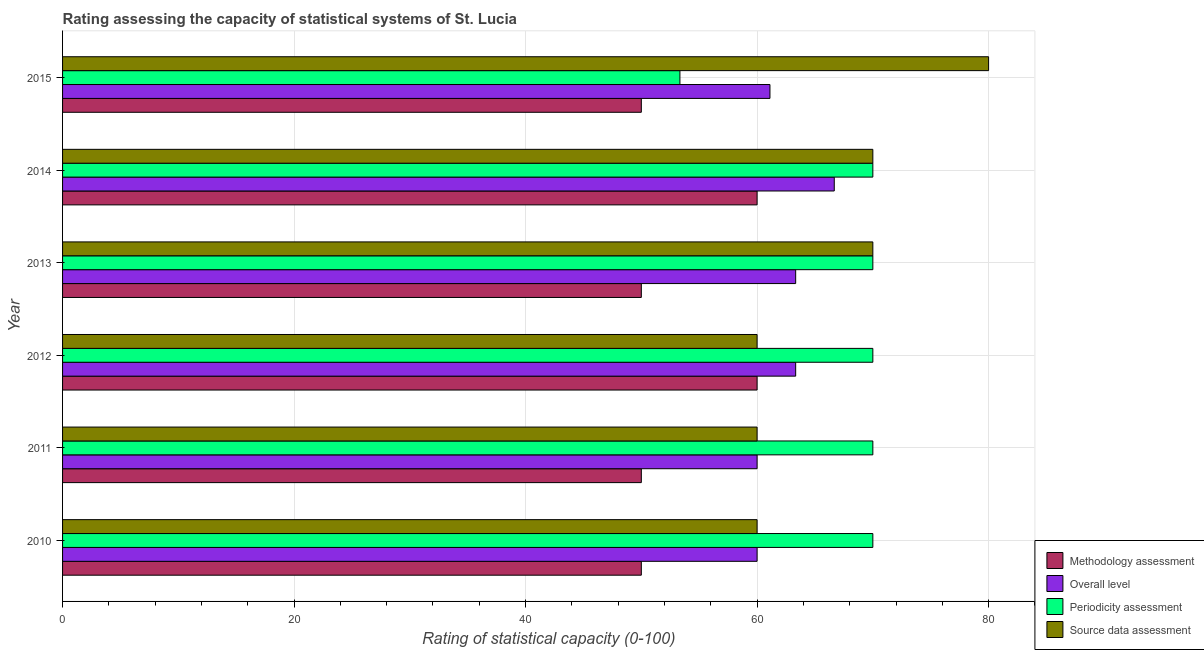How many groups of bars are there?
Provide a succinct answer. 6. What is the label of the 1st group of bars from the top?
Offer a terse response. 2015. What is the periodicity assessment rating in 2015?
Your answer should be very brief. 53.33. Across all years, what is the maximum methodology assessment rating?
Make the answer very short. 60. Across all years, what is the minimum overall level rating?
Offer a very short reply. 60. In which year was the source data assessment rating maximum?
Provide a short and direct response. 2015. In which year was the overall level rating minimum?
Ensure brevity in your answer.  2010. What is the total source data assessment rating in the graph?
Offer a terse response. 400. What is the difference between the methodology assessment rating in 2010 and the periodicity assessment rating in 2011?
Your response must be concise. -20. What is the average methodology assessment rating per year?
Your answer should be compact. 53.33. In the year 2011, what is the difference between the overall level rating and periodicity assessment rating?
Keep it short and to the point. -10. In how many years, is the overall level rating greater than 8 ?
Your answer should be very brief. 6. What is the ratio of the methodology assessment rating in 2010 to that in 2011?
Offer a terse response. 1. Is the overall level rating in 2010 less than that in 2015?
Your response must be concise. Yes. Is the difference between the source data assessment rating in 2011 and 2013 greater than the difference between the overall level rating in 2011 and 2013?
Give a very brief answer. No. What is the difference between the highest and the second highest overall level rating?
Provide a succinct answer. 3.33. What is the difference between the highest and the lowest methodology assessment rating?
Your answer should be compact. 10. Is the sum of the overall level rating in 2010 and 2012 greater than the maximum source data assessment rating across all years?
Give a very brief answer. Yes. What does the 3rd bar from the top in 2012 represents?
Provide a short and direct response. Overall level. What does the 2nd bar from the bottom in 2010 represents?
Provide a short and direct response. Overall level. Are all the bars in the graph horizontal?
Give a very brief answer. Yes. What is the difference between two consecutive major ticks on the X-axis?
Provide a succinct answer. 20. Does the graph contain any zero values?
Your answer should be very brief. No. Does the graph contain grids?
Your answer should be compact. Yes. What is the title of the graph?
Make the answer very short. Rating assessing the capacity of statistical systems of St. Lucia. What is the label or title of the X-axis?
Your answer should be very brief. Rating of statistical capacity (0-100). What is the Rating of statistical capacity (0-100) in Methodology assessment in 2010?
Provide a short and direct response. 50. What is the Rating of statistical capacity (0-100) of Overall level in 2010?
Your answer should be very brief. 60. What is the Rating of statistical capacity (0-100) of Periodicity assessment in 2011?
Make the answer very short. 70. What is the Rating of statistical capacity (0-100) of Overall level in 2012?
Provide a succinct answer. 63.33. What is the Rating of statistical capacity (0-100) in Periodicity assessment in 2012?
Your response must be concise. 70. What is the Rating of statistical capacity (0-100) of Source data assessment in 2012?
Ensure brevity in your answer.  60. What is the Rating of statistical capacity (0-100) in Methodology assessment in 2013?
Give a very brief answer. 50. What is the Rating of statistical capacity (0-100) of Overall level in 2013?
Provide a succinct answer. 63.33. What is the Rating of statistical capacity (0-100) of Source data assessment in 2013?
Offer a terse response. 70. What is the Rating of statistical capacity (0-100) in Methodology assessment in 2014?
Provide a short and direct response. 60. What is the Rating of statistical capacity (0-100) in Overall level in 2014?
Offer a terse response. 66.67. What is the Rating of statistical capacity (0-100) of Methodology assessment in 2015?
Provide a short and direct response. 50. What is the Rating of statistical capacity (0-100) of Overall level in 2015?
Make the answer very short. 61.11. What is the Rating of statistical capacity (0-100) in Periodicity assessment in 2015?
Offer a terse response. 53.33. What is the Rating of statistical capacity (0-100) of Source data assessment in 2015?
Offer a very short reply. 80. Across all years, what is the maximum Rating of statistical capacity (0-100) of Overall level?
Give a very brief answer. 66.67. Across all years, what is the minimum Rating of statistical capacity (0-100) of Methodology assessment?
Give a very brief answer. 50. Across all years, what is the minimum Rating of statistical capacity (0-100) in Overall level?
Ensure brevity in your answer.  60. Across all years, what is the minimum Rating of statistical capacity (0-100) of Periodicity assessment?
Ensure brevity in your answer.  53.33. Across all years, what is the minimum Rating of statistical capacity (0-100) of Source data assessment?
Your answer should be compact. 60. What is the total Rating of statistical capacity (0-100) of Methodology assessment in the graph?
Provide a short and direct response. 320. What is the total Rating of statistical capacity (0-100) in Overall level in the graph?
Provide a succinct answer. 374.44. What is the total Rating of statistical capacity (0-100) in Periodicity assessment in the graph?
Your answer should be compact. 403.33. What is the total Rating of statistical capacity (0-100) in Source data assessment in the graph?
Your answer should be very brief. 400. What is the difference between the Rating of statistical capacity (0-100) in Methodology assessment in 2010 and that in 2011?
Your answer should be very brief. 0. What is the difference between the Rating of statistical capacity (0-100) in Overall level in 2010 and that in 2011?
Ensure brevity in your answer.  0. What is the difference between the Rating of statistical capacity (0-100) in Periodicity assessment in 2010 and that in 2011?
Give a very brief answer. 0. What is the difference between the Rating of statistical capacity (0-100) of Source data assessment in 2010 and that in 2012?
Give a very brief answer. 0. What is the difference between the Rating of statistical capacity (0-100) in Periodicity assessment in 2010 and that in 2013?
Offer a terse response. 0. What is the difference between the Rating of statistical capacity (0-100) in Source data assessment in 2010 and that in 2013?
Provide a succinct answer. -10. What is the difference between the Rating of statistical capacity (0-100) in Overall level in 2010 and that in 2014?
Make the answer very short. -6.67. What is the difference between the Rating of statistical capacity (0-100) of Methodology assessment in 2010 and that in 2015?
Keep it short and to the point. 0. What is the difference between the Rating of statistical capacity (0-100) of Overall level in 2010 and that in 2015?
Your response must be concise. -1.11. What is the difference between the Rating of statistical capacity (0-100) of Periodicity assessment in 2010 and that in 2015?
Ensure brevity in your answer.  16.67. What is the difference between the Rating of statistical capacity (0-100) of Source data assessment in 2010 and that in 2015?
Your answer should be very brief. -20. What is the difference between the Rating of statistical capacity (0-100) in Methodology assessment in 2011 and that in 2012?
Offer a very short reply. -10. What is the difference between the Rating of statistical capacity (0-100) in Overall level in 2011 and that in 2012?
Provide a short and direct response. -3.33. What is the difference between the Rating of statistical capacity (0-100) of Periodicity assessment in 2011 and that in 2012?
Your answer should be compact. 0. What is the difference between the Rating of statistical capacity (0-100) of Source data assessment in 2011 and that in 2012?
Offer a very short reply. 0. What is the difference between the Rating of statistical capacity (0-100) in Methodology assessment in 2011 and that in 2014?
Offer a very short reply. -10. What is the difference between the Rating of statistical capacity (0-100) in Overall level in 2011 and that in 2014?
Give a very brief answer. -6.67. What is the difference between the Rating of statistical capacity (0-100) of Periodicity assessment in 2011 and that in 2014?
Your answer should be very brief. 0. What is the difference between the Rating of statistical capacity (0-100) of Overall level in 2011 and that in 2015?
Offer a very short reply. -1.11. What is the difference between the Rating of statistical capacity (0-100) of Periodicity assessment in 2011 and that in 2015?
Provide a succinct answer. 16.67. What is the difference between the Rating of statistical capacity (0-100) of Overall level in 2012 and that in 2013?
Provide a succinct answer. 0. What is the difference between the Rating of statistical capacity (0-100) in Periodicity assessment in 2012 and that in 2013?
Make the answer very short. 0. What is the difference between the Rating of statistical capacity (0-100) in Source data assessment in 2012 and that in 2013?
Provide a short and direct response. -10. What is the difference between the Rating of statistical capacity (0-100) in Methodology assessment in 2012 and that in 2014?
Ensure brevity in your answer.  0. What is the difference between the Rating of statistical capacity (0-100) of Overall level in 2012 and that in 2014?
Your response must be concise. -3.33. What is the difference between the Rating of statistical capacity (0-100) of Periodicity assessment in 2012 and that in 2014?
Keep it short and to the point. 0. What is the difference between the Rating of statistical capacity (0-100) of Source data assessment in 2012 and that in 2014?
Provide a short and direct response. -10. What is the difference between the Rating of statistical capacity (0-100) in Overall level in 2012 and that in 2015?
Your answer should be very brief. 2.22. What is the difference between the Rating of statistical capacity (0-100) in Periodicity assessment in 2012 and that in 2015?
Your response must be concise. 16.67. What is the difference between the Rating of statistical capacity (0-100) of Source data assessment in 2012 and that in 2015?
Provide a succinct answer. -20. What is the difference between the Rating of statistical capacity (0-100) in Overall level in 2013 and that in 2014?
Provide a succinct answer. -3.33. What is the difference between the Rating of statistical capacity (0-100) of Periodicity assessment in 2013 and that in 2014?
Provide a short and direct response. 0. What is the difference between the Rating of statistical capacity (0-100) in Source data assessment in 2013 and that in 2014?
Your answer should be compact. 0. What is the difference between the Rating of statistical capacity (0-100) in Methodology assessment in 2013 and that in 2015?
Your answer should be compact. 0. What is the difference between the Rating of statistical capacity (0-100) in Overall level in 2013 and that in 2015?
Offer a very short reply. 2.22. What is the difference between the Rating of statistical capacity (0-100) of Periodicity assessment in 2013 and that in 2015?
Offer a very short reply. 16.67. What is the difference between the Rating of statistical capacity (0-100) in Source data assessment in 2013 and that in 2015?
Your answer should be compact. -10. What is the difference between the Rating of statistical capacity (0-100) of Methodology assessment in 2014 and that in 2015?
Ensure brevity in your answer.  10. What is the difference between the Rating of statistical capacity (0-100) in Overall level in 2014 and that in 2015?
Your response must be concise. 5.56. What is the difference between the Rating of statistical capacity (0-100) of Periodicity assessment in 2014 and that in 2015?
Provide a succinct answer. 16.67. What is the difference between the Rating of statistical capacity (0-100) in Methodology assessment in 2010 and the Rating of statistical capacity (0-100) in Source data assessment in 2011?
Give a very brief answer. -10. What is the difference between the Rating of statistical capacity (0-100) of Overall level in 2010 and the Rating of statistical capacity (0-100) of Periodicity assessment in 2011?
Ensure brevity in your answer.  -10. What is the difference between the Rating of statistical capacity (0-100) in Methodology assessment in 2010 and the Rating of statistical capacity (0-100) in Overall level in 2012?
Provide a succinct answer. -13.33. What is the difference between the Rating of statistical capacity (0-100) of Methodology assessment in 2010 and the Rating of statistical capacity (0-100) of Periodicity assessment in 2012?
Give a very brief answer. -20. What is the difference between the Rating of statistical capacity (0-100) of Methodology assessment in 2010 and the Rating of statistical capacity (0-100) of Source data assessment in 2012?
Your response must be concise. -10. What is the difference between the Rating of statistical capacity (0-100) of Overall level in 2010 and the Rating of statistical capacity (0-100) of Periodicity assessment in 2012?
Give a very brief answer. -10. What is the difference between the Rating of statistical capacity (0-100) in Methodology assessment in 2010 and the Rating of statistical capacity (0-100) in Overall level in 2013?
Offer a very short reply. -13.33. What is the difference between the Rating of statistical capacity (0-100) of Methodology assessment in 2010 and the Rating of statistical capacity (0-100) of Periodicity assessment in 2013?
Give a very brief answer. -20. What is the difference between the Rating of statistical capacity (0-100) of Methodology assessment in 2010 and the Rating of statistical capacity (0-100) of Source data assessment in 2013?
Ensure brevity in your answer.  -20. What is the difference between the Rating of statistical capacity (0-100) in Overall level in 2010 and the Rating of statistical capacity (0-100) in Periodicity assessment in 2013?
Keep it short and to the point. -10. What is the difference between the Rating of statistical capacity (0-100) of Overall level in 2010 and the Rating of statistical capacity (0-100) of Source data assessment in 2013?
Make the answer very short. -10. What is the difference between the Rating of statistical capacity (0-100) of Periodicity assessment in 2010 and the Rating of statistical capacity (0-100) of Source data assessment in 2013?
Give a very brief answer. 0. What is the difference between the Rating of statistical capacity (0-100) of Methodology assessment in 2010 and the Rating of statistical capacity (0-100) of Overall level in 2014?
Ensure brevity in your answer.  -16.67. What is the difference between the Rating of statistical capacity (0-100) of Methodology assessment in 2010 and the Rating of statistical capacity (0-100) of Periodicity assessment in 2014?
Make the answer very short. -20. What is the difference between the Rating of statistical capacity (0-100) of Methodology assessment in 2010 and the Rating of statistical capacity (0-100) of Source data assessment in 2014?
Your response must be concise. -20. What is the difference between the Rating of statistical capacity (0-100) of Overall level in 2010 and the Rating of statistical capacity (0-100) of Source data assessment in 2014?
Provide a short and direct response. -10. What is the difference between the Rating of statistical capacity (0-100) in Periodicity assessment in 2010 and the Rating of statistical capacity (0-100) in Source data assessment in 2014?
Keep it short and to the point. 0. What is the difference between the Rating of statistical capacity (0-100) of Methodology assessment in 2010 and the Rating of statistical capacity (0-100) of Overall level in 2015?
Ensure brevity in your answer.  -11.11. What is the difference between the Rating of statistical capacity (0-100) in Methodology assessment in 2010 and the Rating of statistical capacity (0-100) in Source data assessment in 2015?
Make the answer very short. -30. What is the difference between the Rating of statistical capacity (0-100) of Periodicity assessment in 2010 and the Rating of statistical capacity (0-100) of Source data assessment in 2015?
Ensure brevity in your answer.  -10. What is the difference between the Rating of statistical capacity (0-100) of Methodology assessment in 2011 and the Rating of statistical capacity (0-100) of Overall level in 2012?
Offer a terse response. -13.33. What is the difference between the Rating of statistical capacity (0-100) in Methodology assessment in 2011 and the Rating of statistical capacity (0-100) in Periodicity assessment in 2012?
Provide a succinct answer. -20. What is the difference between the Rating of statistical capacity (0-100) in Methodology assessment in 2011 and the Rating of statistical capacity (0-100) in Source data assessment in 2012?
Give a very brief answer. -10. What is the difference between the Rating of statistical capacity (0-100) in Methodology assessment in 2011 and the Rating of statistical capacity (0-100) in Overall level in 2013?
Your answer should be compact. -13.33. What is the difference between the Rating of statistical capacity (0-100) in Methodology assessment in 2011 and the Rating of statistical capacity (0-100) in Periodicity assessment in 2013?
Your response must be concise. -20. What is the difference between the Rating of statistical capacity (0-100) of Methodology assessment in 2011 and the Rating of statistical capacity (0-100) of Overall level in 2014?
Keep it short and to the point. -16.67. What is the difference between the Rating of statistical capacity (0-100) in Overall level in 2011 and the Rating of statistical capacity (0-100) in Periodicity assessment in 2014?
Offer a terse response. -10. What is the difference between the Rating of statistical capacity (0-100) of Methodology assessment in 2011 and the Rating of statistical capacity (0-100) of Overall level in 2015?
Offer a very short reply. -11.11. What is the difference between the Rating of statistical capacity (0-100) in Methodology assessment in 2011 and the Rating of statistical capacity (0-100) in Source data assessment in 2015?
Ensure brevity in your answer.  -30. What is the difference between the Rating of statistical capacity (0-100) of Overall level in 2011 and the Rating of statistical capacity (0-100) of Source data assessment in 2015?
Keep it short and to the point. -20. What is the difference between the Rating of statistical capacity (0-100) of Periodicity assessment in 2011 and the Rating of statistical capacity (0-100) of Source data assessment in 2015?
Ensure brevity in your answer.  -10. What is the difference between the Rating of statistical capacity (0-100) of Methodology assessment in 2012 and the Rating of statistical capacity (0-100) of Periodicity assessment in 2013?
Offer a terse response. -10. What is the difference between the Rating of statistical capacity (0-100) of Overall level in 2012 and the Rating of statistical capacity (0-100) of Periodicity assessment in 2013?
Offer a very short reply. -6.67. What is the difference between the Rating of statistical capacity (0-100) in Overall level in 2012 and the Rating of statistical capacity (0-100) in Source data assessment in 2013?
Make the answer very short. -6.67. What is the difference between the Rating of statistical capacity (0-100) in Periodicity assessment in 2012 and the Rating of statistical capacity (0-100) in Source data assessment in 2013?
Give a very brief answer. 0. What is the difference between the Rating of statistical capacity (0-100) of Methodology assessment in 2012 and the Rating of statistical capacity (0-100) of Overall level in 2014?
Your answer should be compact. -6.67. What is the difference between the Rating of statistical capacity (0-100) in Overall level in 2012 and the Rating of statistical capacity (0-100) in Periodicity assessment in 2014?
Your response must be concise. -6.67. What is the difference between the Rating of statistical capacity (0-100) in Overall level in 2012 and the Rating of statistical capacity (0-100) in Source data assessment in 2014?
Ensure brevity in your answer.  -6.67. What is the difference between the Rating of statistical capacity (0-100) in Methodology assessment in 2012 and the Rating of statistical capacity (0-100) in Overall level in 2015?
Your answer should be compact. -1.11. What is the difference between the Rating of statistical capacity (0-100) in Methodology assessment in 2012 and the Rating of statistical capacity (0-100) in Periodicity assessment in 2015?
Keep it short and to the point. 6.67. What is the difference between the Rating of statistical capacity (0-100) in Overall level in 2012 and the Rating of statistical capacity (0-100) in Periodicity assessment in 2015?
Make the answer very short. 10. What is the difference between the Rating of statistical capacity (0-100) of Overall level in 2012 and the Rating of statistical capacity (0-100) of Source data assessment in 2015?
Keep it short and to the point. -16.67. What is the difference between the Rating of statistical capacity (0-100) of Periodicity assessment in 2012 and the Rating of statistical capacity (0-100) of Source data assessment in 2015?
Keep it short and to the point. -10. What is the difference between the Rating of statistical capacity (0-100) in Methodology assessment in 2013 and the Rating of statistical capacity (0-100) in Overall level in 2014?
Your response must be concise. -16.67. What is the difference between the Rating of statistical capacity (0-100) of Methodology assessment in 2013 and the Rating of statistical capacity (0-100) of Source data assessment in 2014?
Give a very brief answer. -20. What is the difference between the Rating of statistical capacity (0-100) in Overall level in 2013 and the Rating of statistical capacity (0-100) in Periodicity assessment in 2014?
Your answer should be compact. -6.67. What is the difference between the Rating of statistical capacity (0-100) in Overall level in 2013 and the Rating of statistical capacity (0-100) in Source data assessment in 2014?
Keep it short and to the point. -6.67. What is the difference between the Rating of statistical capacity (0-100) in Methodology assessment in 2013 and the Rating of statistical capacity (0-100) in Overall level in 2015?
Give a very brief answer. -11.11. What is the difference between the Rating of statistical capacity (0-100) of Methodology assessment in 2013 and the Rating of statistical capacity (0-100) of Periodicity assessment in 2015?
Provide a succinct answer. -3.33. What is the difference between the Rating of statistical capacity (0-100) in Overall level in 2013 and the Rating of statistical capacity (0-100) in Source data assessment in 2015?
Your answer should be very brief. -16.67. What is the difference between the Rating of statistical capacity (0-100) of Methodology assessment in 2014 and the Rating of statistical capacity (0-100) of Overall level in 2015?
Provide a short and direct response. -1.11. What is the difference between the Rating of statistical capacity (0-100) in Methodology assessment in 2014 and the Rating of statistical capacity (0-100) in Periodicity assessment in 2015?
Provide a short and direct response. 6.67. What is the difference between the Rating of statistical capacity (0-100) of Methodology assessment in 2014 and the Rating of statistical capacity (0-100) of Source data assessment in 2015?
Provide a short and direct response. -20. What is the difference between the Rating of statistical capacity (0-100) of Overall level in 2014 and the Rating of statistical capacity (0-100) of Periodicity assessment in 2015?
Make the answer very short. 13.33. What is the difference between the Rating of statistical capacity (0-100) in Overall level in 2014 and the Rating of statistical capacity (0-100) in Source data assessment in 2015?
Give a very brief answer. -13.33. What is the difference between the Rating of statistical capacity (0-100) of Periodicity assessment in 2014 and the Rating of statistical capacity (0-100) of Source data assessment in 2015?
Provide a succinct answer. -10. What is the average Rating of statistical capacity (0-100) of Methodology assessment per year?
Make the answer very short. 53.33. What is the average Rating of statistical capacity (0-100) in Overall level per year?
Offer a very short reply. 62.41. What is the average Rating of statistical capacity (0-100) of Periodicity assessment per year?
Provide a short and direct response. 67.22. What is the average Rating of statistical capacity (0-100) in Source data assessment per year?
Make the answer very short. 66.67. In the year 2010, what is the difference between the Rating of statistical capacity (0-100) of Methodology assessment and Rating of statistical capacity (0-100) of Overall level?
Offer a terse response. -10. In the year 2010, what is the difference between the Rating of statistical capacity (0-100) of Overall level and Rating of statistical capacity (0-100) of Periodicity assessment?
Make the answer very short. -10. In the year 2011, what is the difference between the Rating of statistical capacity (0-100) of Methodology assessment and Rating of statistical capacity (0-100) of Overall level?
Make the answer very short. -10. In the year 2011, what is the difference between the Rating of statistical capacity (0-100) in Methodology assessment and Rating of statistical capacity (0-100) in Source data assessment?
Provide a short and direct response. -10. In the year 2011, what is the difference between the Rating of statistical capacity (0-100) in Overall level and Rating of statistical capacity (0-100) in Periodicity assessment?
Provide a succinct answer. -10. In the year 2011, what is the difference between the Rating of statistical capacity (0-100) in Overall level and Rating of statistical capacity (0-100) in Source data assessment?
Your answer should be very brief. 0. In the year 2012, what is the difference between the Rating of statistical capacity (0-100) of Methodology assessment and Rating of statistical capacity (0-100) of Overall level?
Make the answer very short. -3.33. In the year 2012, what is the difference between the Rating of statistical capacity (0-100) in Methodology assessment and Rating of statistical capacity (0-100) in Periodicity assessment?
Offer a very short reply. -10. In the year 2012, what is the difference between the Rating of statistical capacity (0-100) in Overall level and Rating of statistical capacity (0-100) in Periodicity assessment?
Give a very brief answer. -6.67. In the year 2012, what is the difference between the Rating of statistical capacity (0-100) in Overall level and Rating of statistical capacity (0-100) in Source data assessment?
Provide a succinct answer. 3.33. In the year 2012, what is the difference between the Rating of statistical capacity (0-100) of Periodicity assessment and Rating of statistical capacity (0-100) of Source data assessment?
Give a very brief answer. 10. In the year 2013, what is the difference between the Rating of statistical capacity (0-100) in Methodology assessment and Rating of statistical capacity (0-100) in Overall level?
Make the answer very short. -13.33. In the year 2013, what is the difference between the Rating of statistical capacity (0-100) in Methodology assessment and Rating of statistical capacity (0-100) in Periodicity assessment?
Your answer should be very brief. -20. In the year 2013, what is the difference between the Rating of statistical capacity (0-100) in Methodology assessment and Rating of statistical capacity (0-100) in Source data assessment?
Make the answer very short. -20. In the year 2013, what is the difference between the Rating of statistical capacity (0-100) of Overall level and Rating of statistical capacity (0-100) of Periodicity assessment?
Your response must be concise. -6.67. In the year 2013, what is the difference between the Rating of statistical capacity (0-100) of Overall level and Rating of statistical capacity (0-100) of Source data assessment?
Your answer should be very brief. -6.67. In the year 2014, what is the difference between the Rating of statistical capacity (0-100) in Methodology assessment and Rating of statistical capacity (0-100) in Overall level?
Your answer should be compact. -6.67. In the year 2014, what is the difference between the Rating of statistical capacity (0-100) of Methodology assessment and Rating of statistical capacity (0-100) of Source data assessment?
Keep it short and to the point. -10. In the year 2014, what is the difference between the Rating of statistical capacity (0-100) in Overall level and Rating of statistical capacity (0-100) in Periodicity assessment?
Provide a short and direct response. -3.33. In the year 2015, what is the difference between the Rating of statistical capacity (0-100) in Methodology assessment and Rating of statistical capacity (0-100) in Overall level?
Provide a short and direct response. -11.11. In the year 2015, what is the difference between the Rating of statistical capacity (0-100) in Methodology assessment and Rating of statistical capacity (0-100) in Source data assessment?
Your response must be concise. -30. In the year 2015, what is the difference between the Rating of statistical capacity (0-100) in Overall level and Rating of statistical capacity (0-100) in Periodicity assessment?
Offer a very short reply. 7.78. In the year 2015, what is the difference between the Rating of statistical capacity (0-100) of Overall level and Rating of statistical capacity (0-100) of Source data assessment?
Give a very brief answer. -18.89. In the year 2015, what is the difference between the Rating of statistical capacity (0-100) of Periodicity assessment and Rating of statistical capacity (0-100) of Source data assessment?
Your answer should be very brief. -26.67. What is the ratio of the Rating of statistical capacity (0-100) in Methodology assessment in 2010 to that in 2012?
Give a very brief answer. 0.83. What is the ratio of the Rating of statistical capacity (0-100) of Overall level in 2010 to that in 2012?
Your answer should be compact. 0.95. What is the ratio of the Rating of statistical capacity (0-100) of Periodicity assessment in 2010 to that in 2012?
Provide a succinct answer. 1. What is the ratio of the Rating of statistical capacity (0-100) in Source data assessment in 2010 to that in 2012?
Keep it short and to the point. 1. What is the ratio of the Rating of statistical capacity (0-100) in Methodology assessment in 2010 to that in 2013?
Ensure brevity in your answer.  1. What is the ratio of the Rating of statistical capacity (0-100) in Overall level in 2010 to that in 2014?
Give a very brief answer. 0.9. What is the ratio of the Rating of statistical capacity (0-100) in Periodicity assessment in 2010 to that in 2014?
Give a very brief answer. 1. What is the ratio of the Rating of statistical capacity (0-100) in Methodology assessment in 2010 to that in 2015?
Your response must be concise. 1. What is the ratio of the Rating of statistical capacity (0-100) in Overall level in 2010 to that in 2015?
Give a very brief answer. 0.98. What is the ratio of the Rating of statistical capacity (0-100) of Periodicity assessment in 2010 to that in 2015?
Offer a very short reply. 1.31. What is the ratio of the Rating of statistical capacity (0-100) in Source data assessment in 2010 to that in 2015?
Offer a very short reply. 0.75. What is the ratio of the Rating of statistical capacity (0-100) of Methodology assessment in 2011 to that in 2013?
Your answer should be very brief. 1. What is the ratio of the Rating of statistical capacity (0-100) of Source data assessment in 2011 to that in 2013?
Your response must be concise. 0.86. What is the ratio of the Rating of statistical capacity (0-100) in Methodology assessment in 2011 to that in 2014?
Give a very brief answer. 0.83. What is the ratio of the Rating of statistical capacity (0-100) of Overall level in 2011 to that in 2014?
Provide a short and direct response. 0.9. What is the ratio of the Rating of statistical capacity (0-100) of Periodicity assessment in 2011 to that in 2014?
Your answer should be compact. 1. What is the ratio of the Rating of statistical capacity (0-100) in Source data assessment in 2011 to that in 2014?
Provide a succinct answer. 0.86. What is the ratio of the Rating of statistical capacity (0-100) of Overall level in 2011 to that in 2015?
Give a very brief answer. 0.98. What is the ratio of the Rating of statistical capacity (0-100) of Periodicity assessment in 2011 to that in 2015?
Offer a terse response. 1.31. What is the ratio of the Rating of statistical capacity (0-100) in Methodology assessment in 2012 to that in 2013?
Offer a very short reply. 1.2. What is the ratio of the Rating of statistical capacity (0-100) in Periodicity assessment in 2012 to that in 2013?
Offer a very short reply. 1. What is the ratio of the Rating of statistical capacity (0-100) in Source data assessment in 2012 to that in 2013?
Provide a short and direct response. 0.86. What is the ratio of the Rating of statistical capacity (0-100) of Source data assessment in 2012 to that in 2014?
Your answer should be compact. 0.86. What is the ratio of the Rating of statistical capacity (0-100) of Methodology assessment in 2012 to that in 2015?
Offer a terse response. 1.2. What is the ratio of the Rating of statistical capacity (0-100) in Overall level in 2012 to that in 2015?
Offer a very short reply. 1.04. What is the ratio of the Rating of statistical capacity (0-100) of Periodicity assessment in 2012 to that in 2015?
Provide a succinct answer. 1.31. What is the ratio of the Rating of statistical capacity (0-100) of Source data assessment in 2012 to that in 2015?
Provide a short and direct response. 0.75. What is the ratio of the Rating of statistical capacity (0-100) in Methodology assessment in 2013 to that in 2014?
Provide a short and direct response. 0.83. What is the ratio of the Rating of statistical capacity (0-100) of Periodicity assessment in 2013 to that in 2014?
Ensure brevity in your answer.  1. What is the ratio of the Rating of statistical capacity (0-100) of Source data assessment in 2013 to that in 2014?
Your response must be concise. 1. What is the ratio of the Rating of statistical capacity (0-100) of Methodology assessment in 2013 to that in 2015?
Ensure brevity in your answer.  1. What is the ratio of the Rating of statistical capacity (0-100) of Overall level in 2013 to that in 2015?
Your answer should be compact. 1.04. What is the ratio of the Rating of statistical capacity (0-100) of Periodicity assessment in 2013 to that in 2015?
Ensure brevity in your answer.  1.31. What is the ratio of the Rating of statistical capacity (0-100) of Methodology assessment in 2014 to that in 2015?
Your answer should be compact. 1.2. What is the ratio of the Rating of statistical capacity (0-100) of Overall level in 2014 to that in 2015?
Give a very brief answer. 1.09. What is the ratio of the Rating of statistical capacity (0-100) of Periodicity assessment in 2014 to that in 2015?
Your response must be concise. 1.31. What is the difference between the highest and the second highest Rating of statistical capacity (0-100) of Overall level?
Your answer should be compact. 3.33. What is the difference between the highest and the second highest Rating of statistical capacity (0-100) in Source data assessment?
Keep it short and to the point. 10. What is the difference between the highest and the lowest Rating of statistical capacity (0-100) in Methodology assessment?
Offer a very short reply. 10. What is the difference between the highest and the lowest Rating of statistical capacity (0-100) of Overall level?
Provide a short and direct response. 6.67. What is the difference between the highest and the lowest Rating of statistical capacity (0-100) in Periodicity assessment?
Make the answer very short. 16.67. What is the difference between the highest and the lowest Rating of statistical capacity (0-100) in Source data assessment?
Ensure brevity in your answer.  20. 